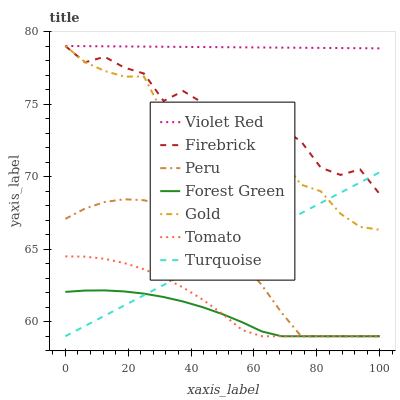Does Gold have the minimum area under the curve?
Answer yes or no. No. Does Gold have the maximum area under the curve?
Answer yes or no. No. Is Violet Red the smoothest?
Answer yes or no. No. Is Violet Red the roughest?
Answer yes or no. No. Does Gold have the lowest value?
Answer yes or no. No. Does Turquoise have the highest value?
Answer yes or no. No. Is Forest Green less than Firebrick?
Answer yes or no. Yes. Is Violet Red greater than Turquoise?
Answer yes or no. Yes. Does Forest Green intersect Firebrick?
Answer yes or no. No. 